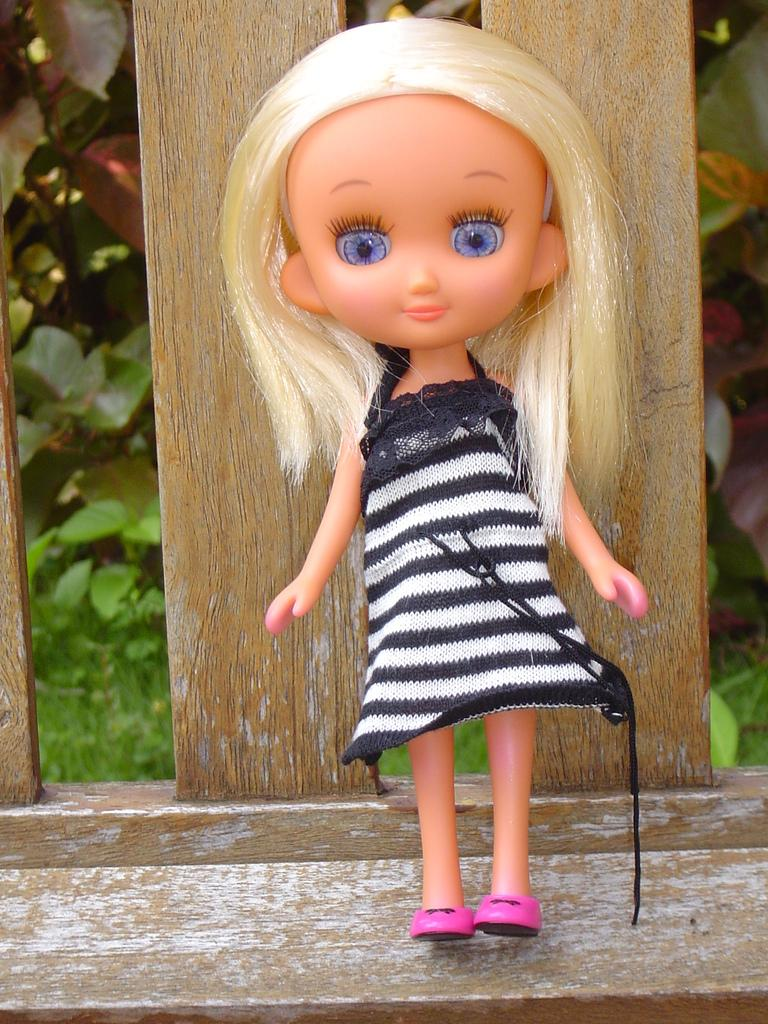What is the main subject in the image? There is a doll in the image. What other object can be seen in the image besides the doll? There is a wooden object in the image. What type of vegetation is visible in the background of the image? There are plants in the background of the image. What title is given to the doll in the image? There is no title given to the doll in the image. Where is the basin located in the image? There is no basin present in the image. 